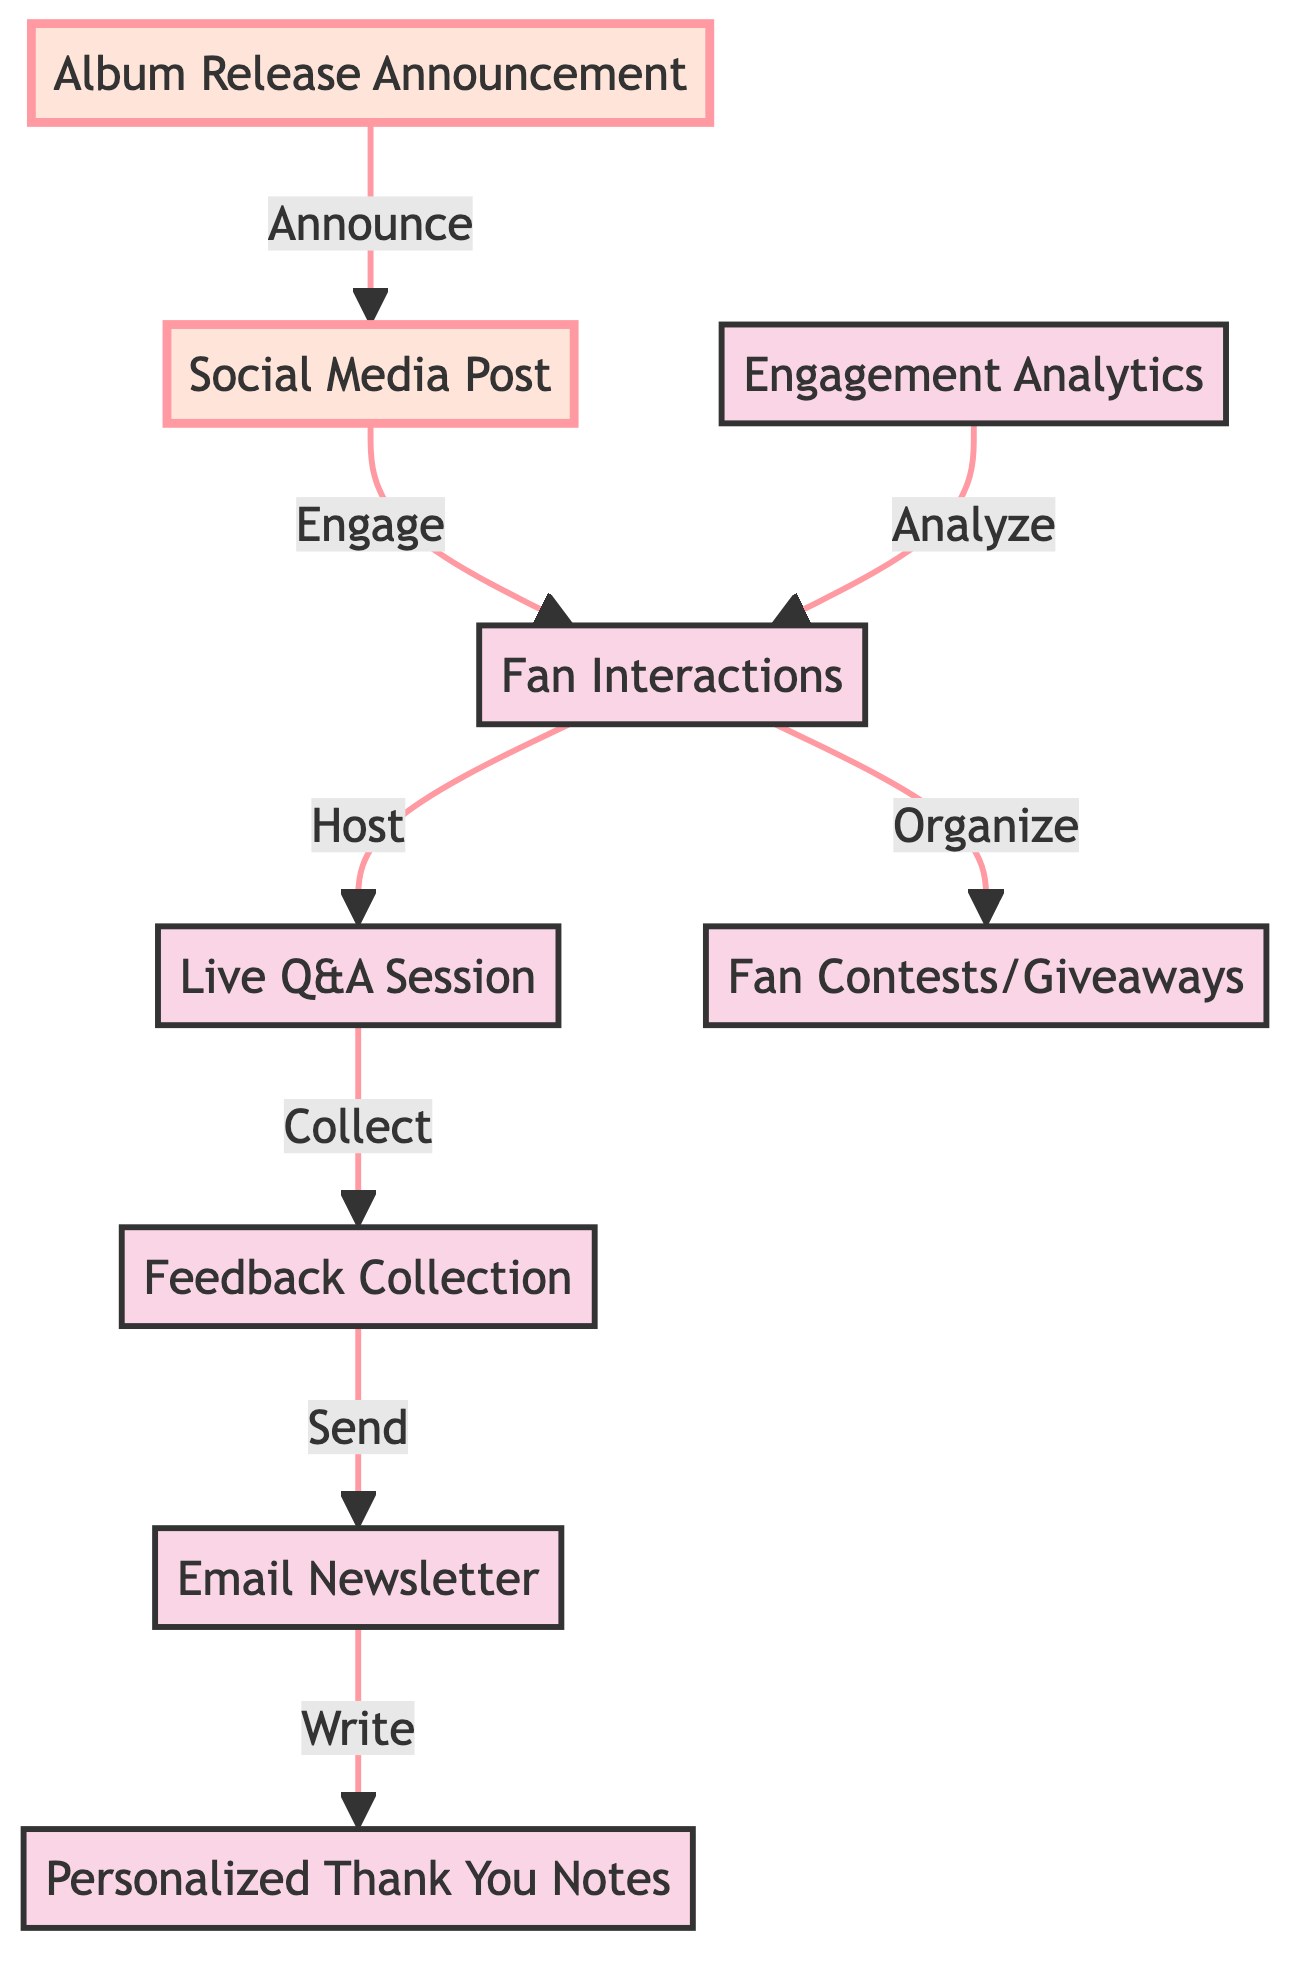What is the starting point of the fan engagement workflow? The diagram indicates that the starting point is the "Album Release Announcement," which leads to the "Social Media Post."
Answer: Album Release Announcement How many nodes are present in the diagram? Counting all the different entities listed, there are 9 nodes present in the diagram that represent various engagement steps.
Answer: 9 Which node follows "Live Q&A Session"? The directed edge shows that after the "Live Q&A Session," the next step is "Feedback Collection," indicating a structured flow of engagement.
Answer: Feedback Collection What is the purpose of the connection between "Feedback Collection" and "Email Newsletter"? The edge directed from "Feedback Collection" to "Email Newsletter" signifies that, after collecting feedback, the next action is to send out an email newsletter to fans.
Answer: Send How do "Engagement Analytics" relate to "Fan Interactions"? "Engagement Analytics" contributes insights that analyze the interactions with fans, impacting how "Fan Interactions" can be further improved based on the collected data.
Answer: Analyze Which two steps are directly linked through a fan-driven activity? The "Fan Interactions" lead to both "Live Q&A Session" and "Fan Contests/Giveaways," highlighting the interactive nature of such engagement activities.
Answer: Live Q&A Session and Fan Contests/Giveaways How does "Social Media Post" relate to "Fan Interactions"? The directed edge indicates that the "Social Media Post" creates an engagement opportunity, leading directly to "Fan Interactions," establishing initial contact with the audience.
Answer: Engage What is the last step indicated in this fan engagement workflow? The flow indicates that the last step in the engagement process is sending "Personalized Thank You Notes" after the "Email Newsletter" is sent, which finalizes the communication cycle.
Answer: Personalized Thank You Notes 